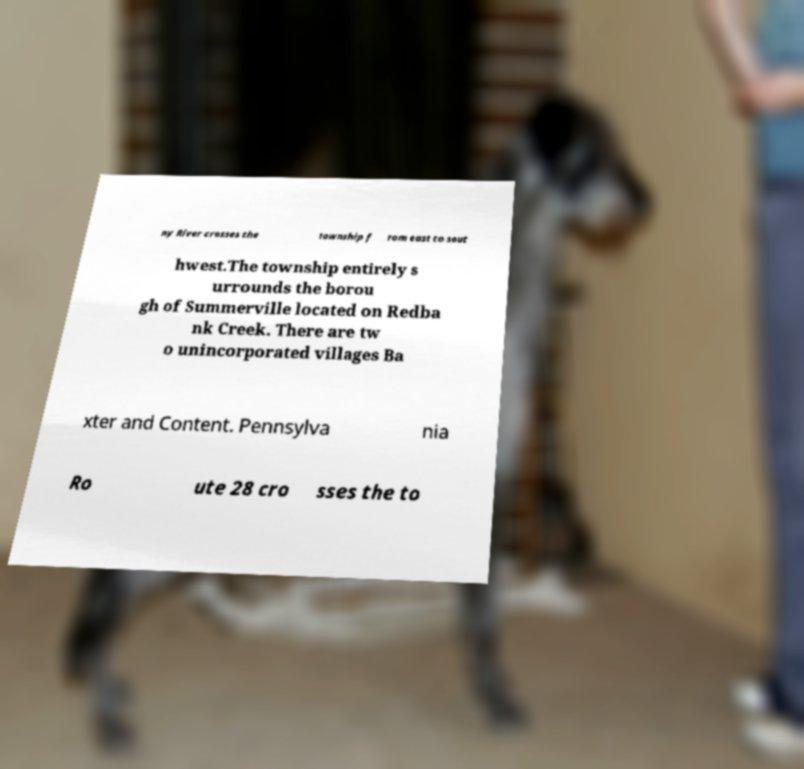Can you read and provide the text displayed in the image?This photo seems to have some interesting text. Can you extract and type it out for me? ny River crosses the township f rom east to sout hwest.The township entirely s urrounds the borou gh of Summerville located on Redba nk Creek. There are tw o unincorporated villages Ba xter and Content. Pennsylva nia Ro ute 28 cro sses the to 